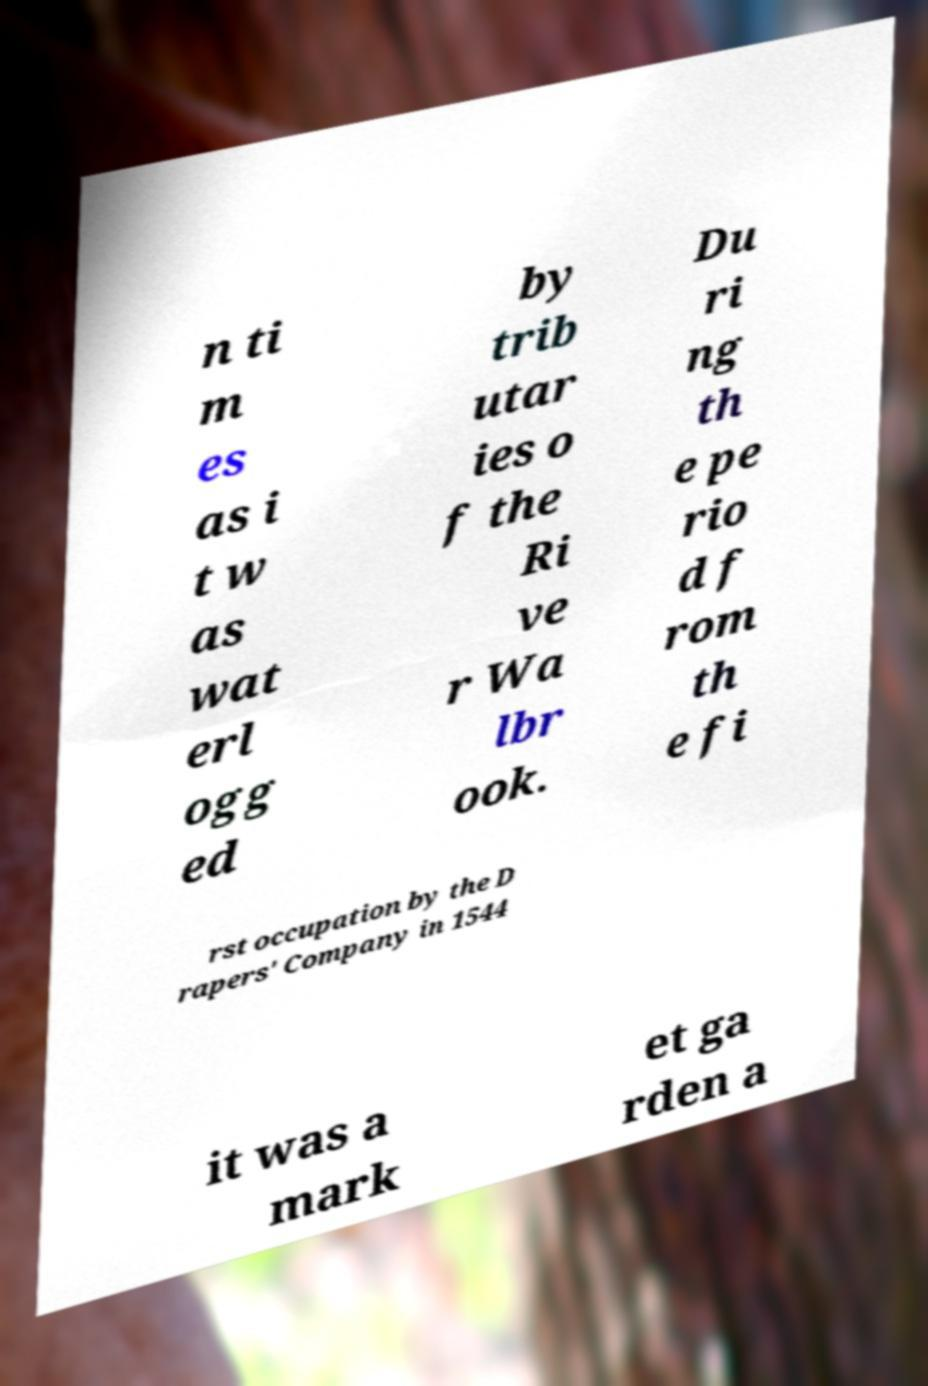For documentation purposes, I need the text within this image transcribed. Could you provide that? n ti m es as i t w as wat erl ogg ed by trib utar ies o f the Ri ve r Wa lbr ook. Du ri ng th e pe rio d f rom th e fi rst occupation by the D rapers' Company in 1544 it was a mark et ga rden a 